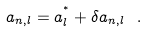<formula> <loc_0><loc_0><loc_500><loc_500>a _ { n , l } = a ^ { ^ { * } } _ { l } + \delta a _ { n , l } \ .</formula> 